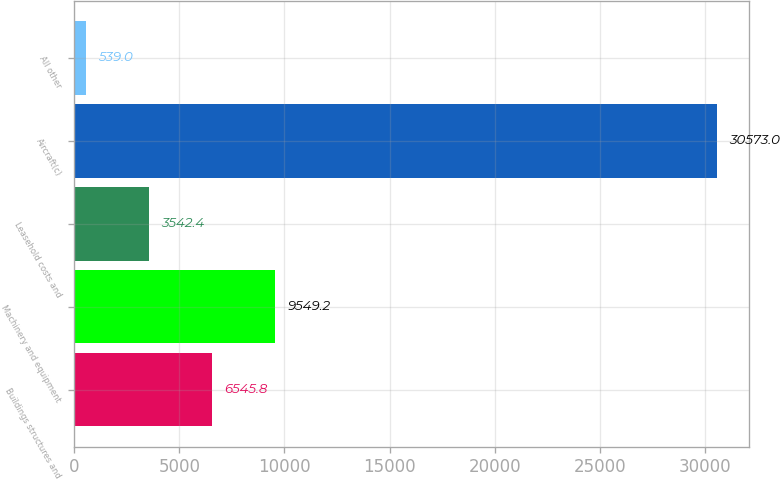Convert chart. <chart><loc_0><loc_0><loc_500><loc_500><bar_chart><fcel>Buildings structures and<fcel>Machinery and equipment<fcel>Leasehold costs and<fcel>Aircraft(c)<fcel>All other<nl><fcel>6545.8<fcel>9549.2<fcel>3542.4<fcel>30573<fcel>539<nl></chart> 